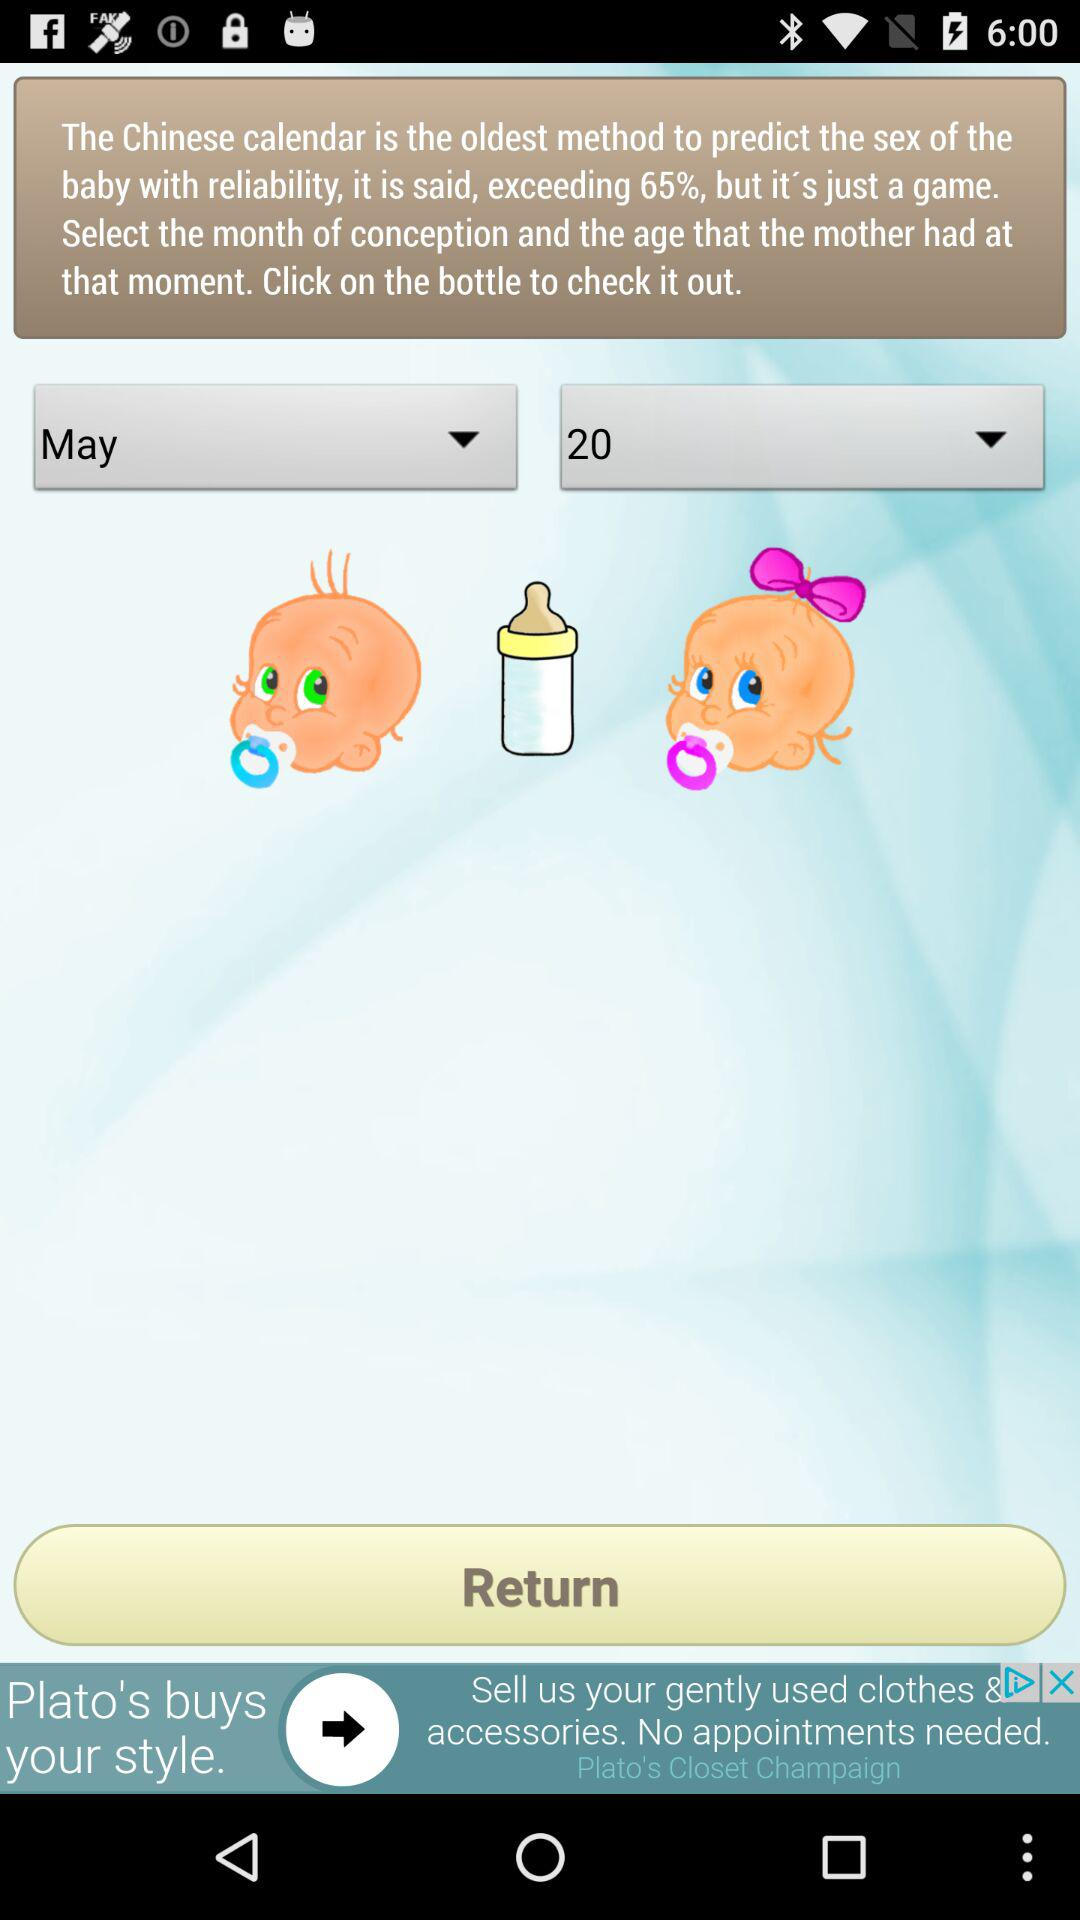What is the month of conception? The month of conception is May. 